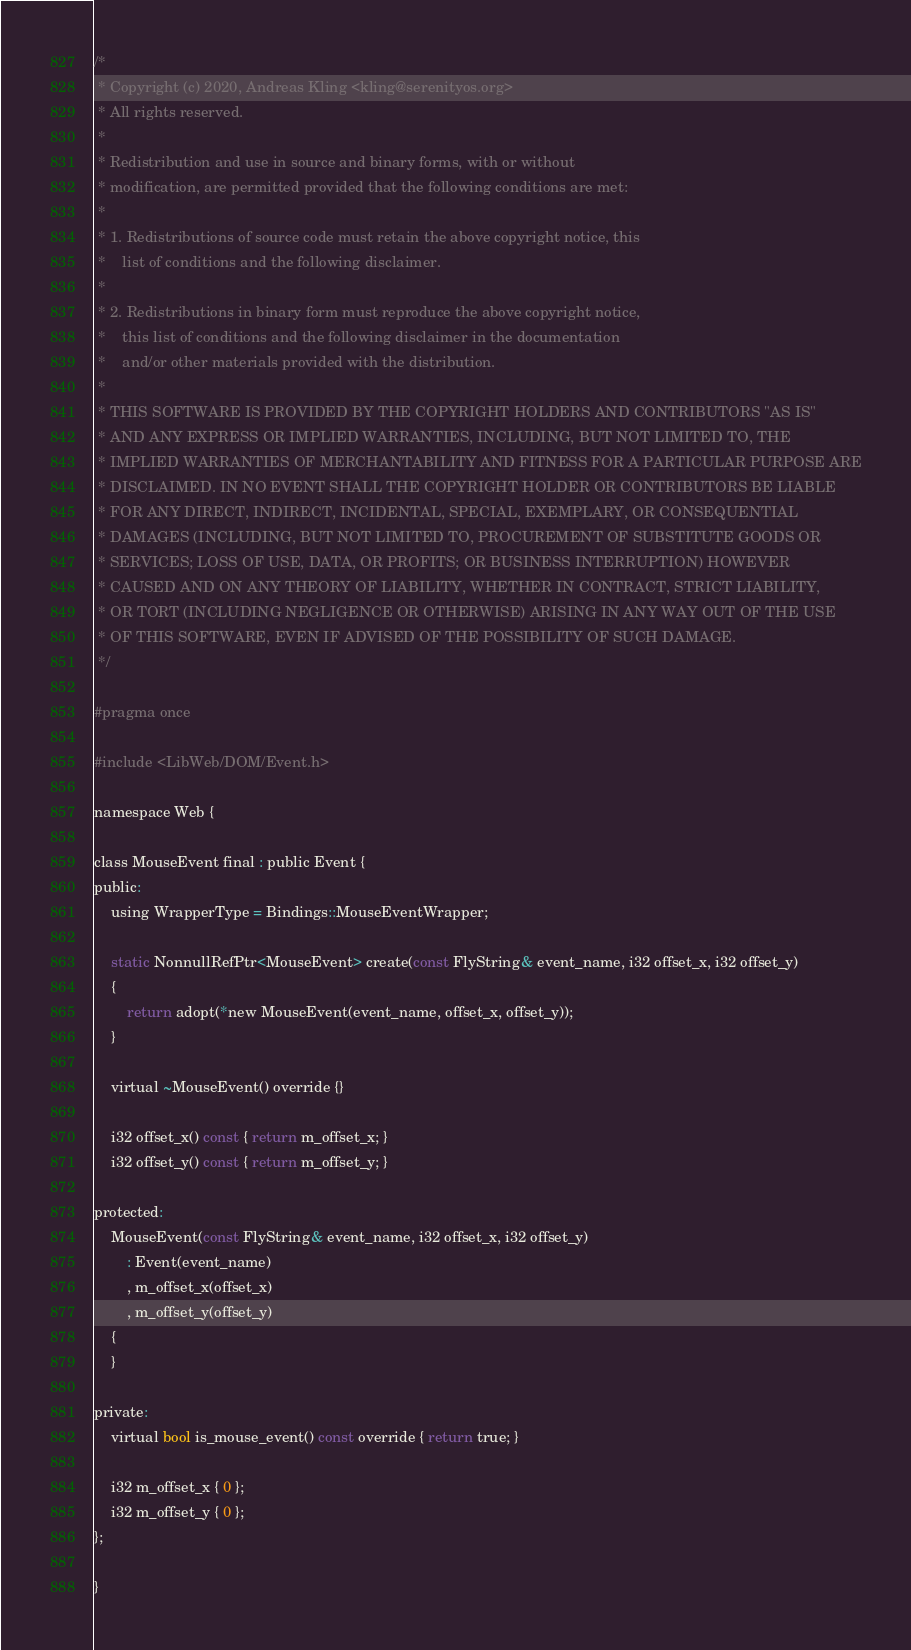Convert code to text. <code><loc_0><loc_0><loc_500><loc_500><_C_>/*
 * Copyright (c) 2020, Andreas Kling <kling@serenityos.org>
 * All rights reserved.
 *
 * Redistribution and use in source and binary forms, with or without
 * modification, are permitted provided that the following conditions are met:
 *
 * 1. Redistributions of source code must retain the above copyright notice, this
 *    list of conditions and the following disclaimer.
 *
 * 2. Redistributions in binary form must reproduce the above copyright notice,
 *    this list of conditions and the following disclaimer in the documentation
 *    and/or other materials provided with the distribution.
 *
 * THIS SOFTWARE IS PROVIDED BY THE COPYRIGHT HOLDERS AND CONTRIBUTORS "AS IS"
 * AND ANY EXPRESS OR IMPLIED WARRANTIES, INCLUDING, BUT NOT LIMITED TO, THE
 * IMPLIED WARRANTIES OF MERCHANTABILITY AND FITNESS FOR A PARTICULAR PURPOSE ARE
 * DISCLAIMED. IN NO EVENT SHALL THE COPYRIGHT HOLDER OR CONTRIBUTORS BE LIABLE
 * FOR ANY DIRECT, INDIRECT, INCIDENTAL, SPECIAL, EXEMPLARY, OR CONSEQUENTIAL
 * DAMAGES (INCLUDING, BUT NOT LIMITED TO, PROCUREMENT OF SUBSTITUTE GOODS OR
 * SERVICES; LOSS OF USE, DATA, OR PROFITS; OR BUSINESS INTERRUPTION) HOWEVER
 * CAUSED AND ON ANY THEORY OF LIABILITY, WHETHER IN CONTRACT, STRICT LIABILITY,
 * OR TORT (INCLUDING NEGLIGENCE OR OTHERWISE) ARISING IN ANY WAY OUT OF THE USE
 * OF THIS SOFTWARE, EVEN IF ADVISED OF THE POSSIBILITY OF SUCH DAMAGE.
 */

#pragma once

#include <LibWeb/DOM/Event.h>

namespace Web {

class MouseEvent final : public Event {
public:
    using WrapperType = Bindings::MouseEventWrapper;

    static NonnullRefPtr<MouseEvent> create(const FlyString& event_name, i32 offset_x, i32 offset_y)
    {
        return adopt(*new MouseEvent(event_name, offset_x, offset_y));
    }

    virtual ~MouseEvent() override {}

    i32 offset_x() const { return m_offset_x; }
    i32 offset_y() const { return m_offset_y; }

protected:
    MouseEvent(const FlyString& event_name, i32 offset_x, i32 offset_y)
        : Event(event_name)
        , m_offset_x(offset_x)
        , m_offset_y(offset_y)
    {
    }

private:
    virtual bool is_mouse_event() const override { return true; }

    i32 m_offset_x { 0 };
    i32 m_offset_y { 0 };
};

}
</code> 